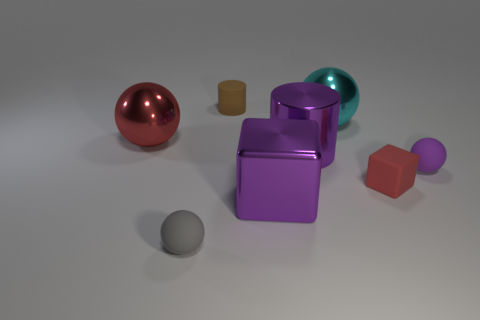How big is the gray ball?
Your answer should be compact. Small. How many tiny objects are either red balls or purple balls?
Your answer should be very brief. 1. There is a rubber sphere that is the same size as the gray object; what color is it?
Ensure brevity in your answer.  Purple. What number of other things are there of the same shape as the red metal object?
Your answer should be compact. 3. Is there a cube made of the same material as the purple cylinder?
Offer a terse response. Yes. Does the block to the left of the red rubber block have the same material as the large ball that is right of the tiny brown matte object?
Provide a succinct answer. Yes. What number of red objects are there?
Keep it short and to the point. 2. What shape is the red thing that is to the right of the purple metallic cube?
Your answer should be compact. Cube. How many other things are the same size as the purple cube?
Ensure brevity in your answer.  3. There is a big thing that is in front of the purple sphere; does it have the same shape as the red thing that is left of the large metal cylinder?
Your answer should be very brief. No. 